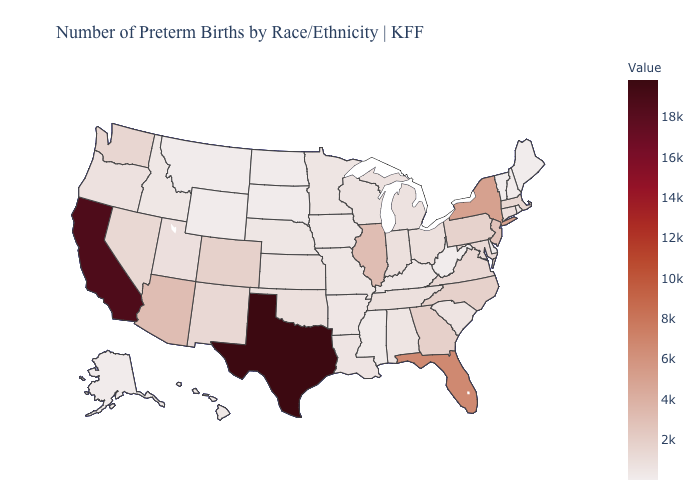Which states have the lowest value in the West?
Be succinct. Montana. Among the states that border Wyoming , does South Dakota have the highest value?
Answer briefly. No. Which states hav the highest value in the Northeast?
Quick response, please. New York. Does the map have missing data?
Quick response, please. No. 